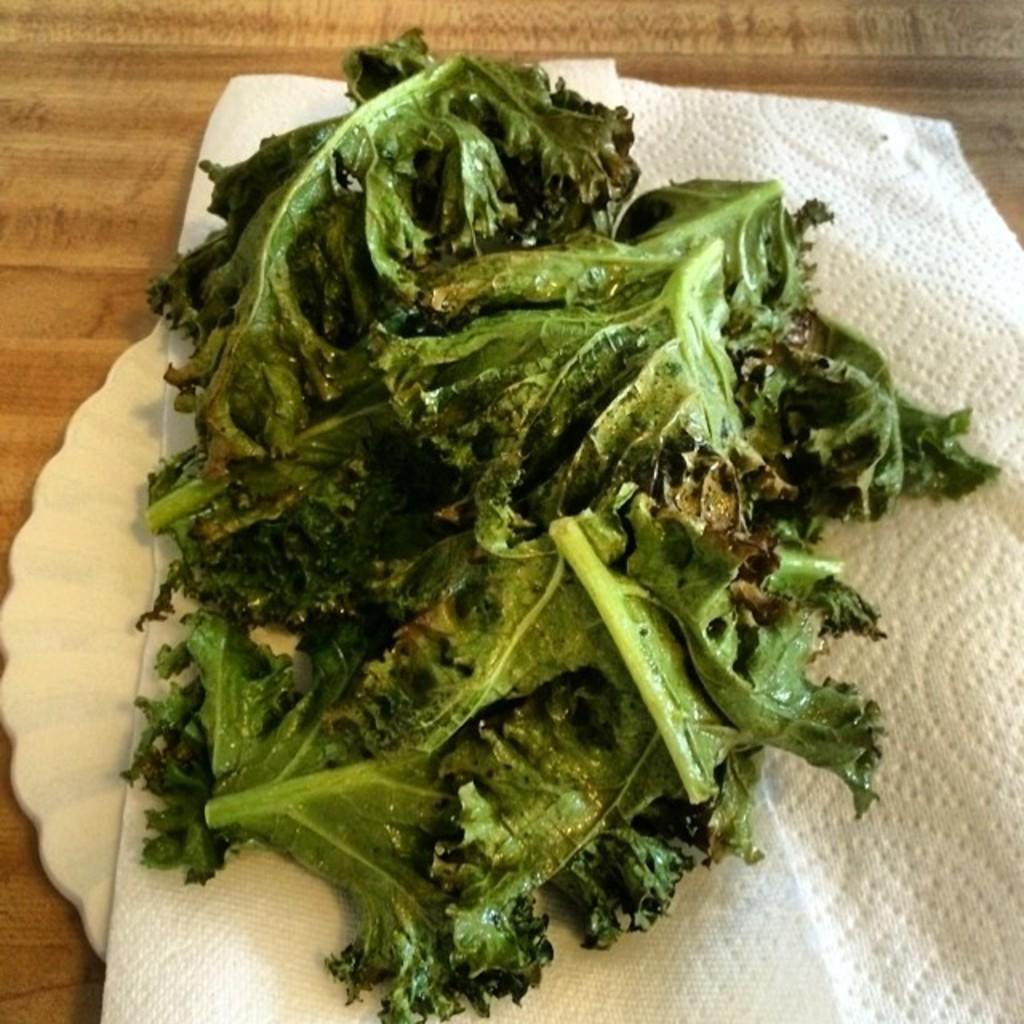In one or two sentences, can you explain what this image depicts? This image is taken indoors. At the bottom of the image there is a table with a plate and tissue on it and on the plate there are a few leafy vegetables. 